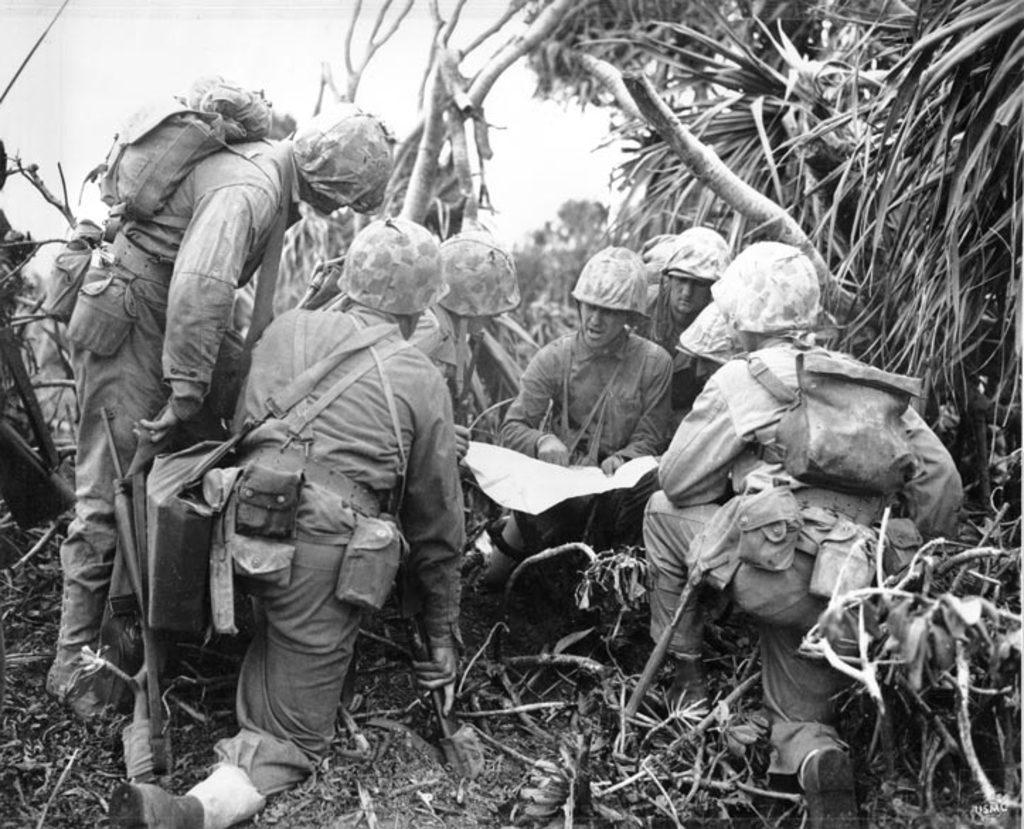What is the main subject in the middle of the image? There is a group of army men in the middle of the image. What can be seen in the background of the image? There are trees in the background of the image. What is visible at the top of the image? The sky is visible at the top of the image. What is the color scheme of the image? The image is in black and white color. What sound does the zebra make in the image? There is no zebra present in the image, so it is not possible to determine the sound it might make. 